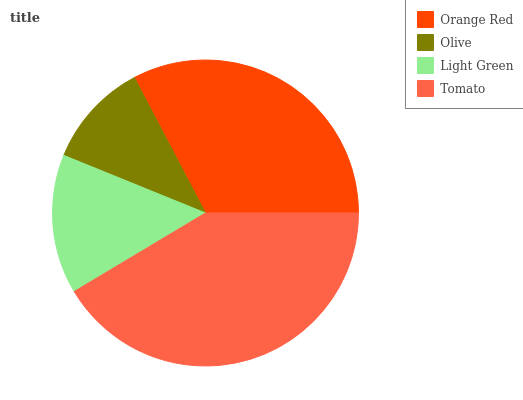Is Olive the minimum?
Answer yes or no. Yes. Is Tomato the maximum?
Answer yes or no. Yes. Is Light Green the minimum?
Answer yes or no. No. Is Light Green the maximum?
Answer yes or no. No. Is Light Green greater than Olive?
Answer yes or no. Yes. Is Olive less than Light Green?
Answer yes or no. Yes. Is Olive greater than Light Green?
Answer yes or no. No. Is Light Green less than Olive?
Answer yes or no. No. Is Orange Red the high median?
Answer yes or no. Yes. Is Light Green the low median?
Answer yes or no. Yes. Is Light Green the high median?
Answer yes or no. No. Is Orange Red the low median?
Answer yes or no. No. 